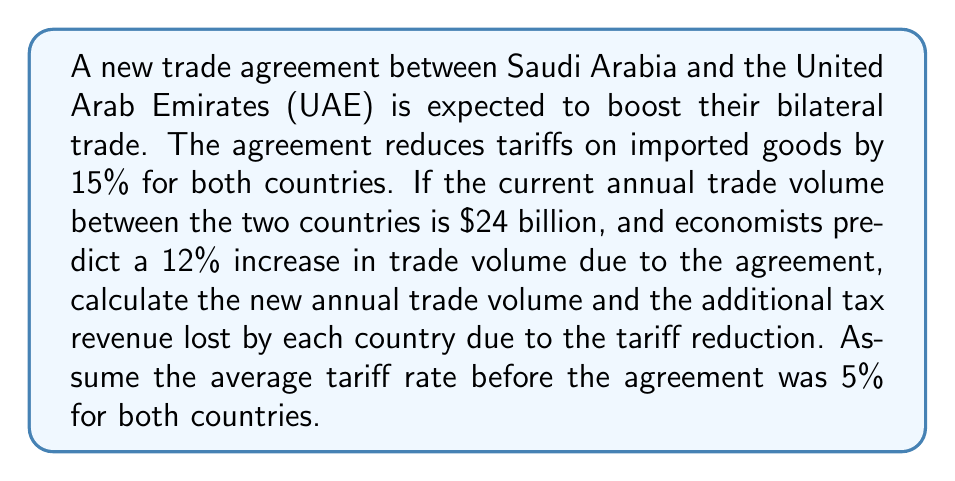Help me with this question. To solve this problem, we'll follow these steps:

1. Calculate the new trade volume after the 12% increase:
   Let $x$ be the new trade volume.
   $$x = 24 \text{ billion} \times (1 + 0.12) = 24 \text{ billion} \times 1.12 = 26.88 \text{ billion}$$

2. Calculate the tax revenue before the agreement:
   $$\text{Tax revenue}_\text{before} = 24 \text{ billion} \times 0.05 = 1.2 \text{ billion}$$

3. Calculate the new tariff rate after the 15% reduction:
   $$\text{New tariff rate} = 5\% \times (1 - 0.15) = 5\% \times 0.85 = 4.25\%$$

4. Calculate the tax revenue after the agreement:
   $$\text{Tax revenue}_\text{after} = 26.88 \text{ billion} \times 0.0425 = 1.1424 \text{ billion}$$

5. Calculate the tax revenue lost due to the agreement:
   $$\text{Tax revenue lost} = 1.2 \text{ billion} - 1.1424 \text{ billion} = 0.0576 \text{ billion} = 57.6 \text{ million}$$

Since both countries have the same tariff rates and reductions, each country will lose the same amount of tax revenue.
Answer: The new annual trade volume will be $26.88 billion. Each country will lose $57.6 million in tax revenue due to the tariff reduction. 